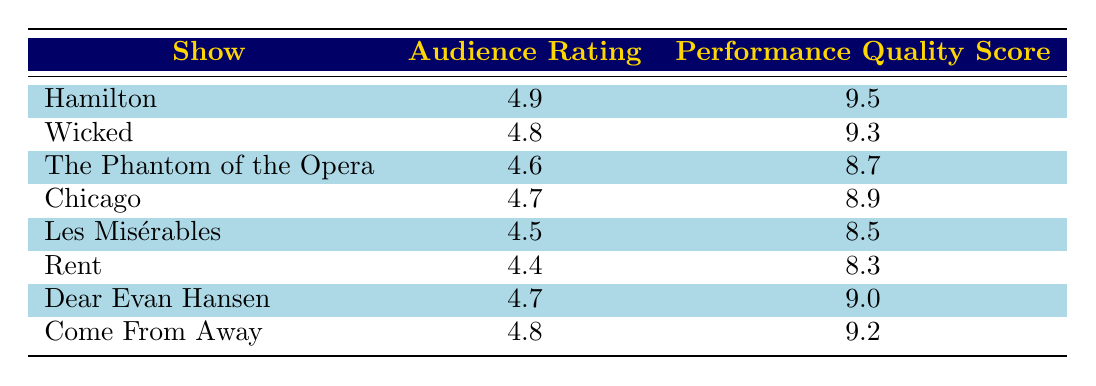What is the Audience Rating for "Wicked"? The table shows the Audience Rating for "Wicked" is listed directly in the second column next to its name.
Answer: 4.8 Which show has the highest Performance Quality Score? By examining the Performance Quality Score in the table, "Hamilton" has the highest score at 9.5.
Answer: Hamilton What is the average Audience Rating of all shows? To calculate the average Audience Rating, sum the values: (4.9 + 4.8 + 4.6 + 4.7 + 4.5 + 4.4 + 4.7 + 4.8) = 37.0. There are 8 shows, so divide by 8: 37.0 / 8 = 4.625.
Answer: 4.625 Is the Performance Quality Score for "Rent" greater than 9? The table indicates that the Performance Quality Score for "Rent" is 8.3, which is less than 9.
Answer: No How many shows have an Audience Rating of 4.7 or higher? The Audience Ratings of 4.7 or higher are for "Hamilton", "Wicked", "Dear Evan Hansen", and "Come From Away." Counting these shows gives us a total of 4.
Answer: 4 What is the difference between the highest and lowest Performance Quality Scores? The highest Performance Quality Score is 9.5 (from "Hamilton") and the lowest is 8.3 (from "Rent"). The difference is 9.5 - 8.3 = 1.2.
Answer: 1.2 Does "Chicago" have a higher Audience Rating than "Les Misérables"? The Audience Rating for "Chicago" is 4.7, while "Les Misérables" has an Audience Rating of 4.5. Since 4.7 is greater than 4.5, the answer is yes.
Answer: Yes What are the Performance Quality Scores for shows with an Audience Rating of 4.6 or lower? The shows with an Audience Rating of 4.6 or lower are "The Phantom of the Opera" (8.7), "Les Misérables" (8.5), and "Rent" (8.3). The Performance Quality Scores are 8.7, 8.5, and 8.3.
Answer: 8.7, 8.5, 8.3 